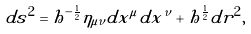<formula> <loc_0><loc_0><loc_500><loc_500>d s ^ { 2 } = h ^ { - \frac { 1 } { 2 } } \eta _ { \mu \nu } d x ^ { \mu } d x ^ { \nu } + h ^ { \frac { 1 } { 2 } } d r ^ { 2 } ,</formula> 